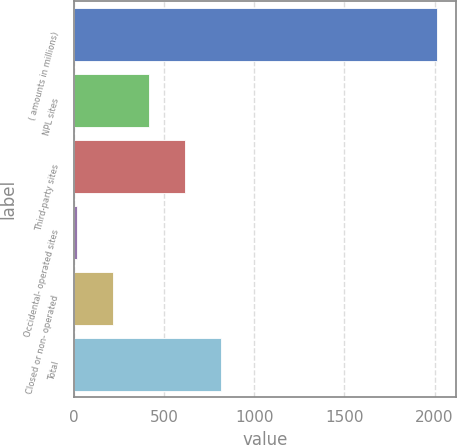Convert chart. <chart><loc_0><loc_0><loc_500><loc_500><bar_chart><fcel>( amounts in millions)<fcel>NPL sites<fcel>Third-party sites<fcel>Occidental- operated sites<fcel>Closed or non- operated<fcel>Total<nl><fcel>2016<fcel>416.8<fcel>616.7<fcel>17<fcel>216.9<fcel>816.6<nl></chart> 